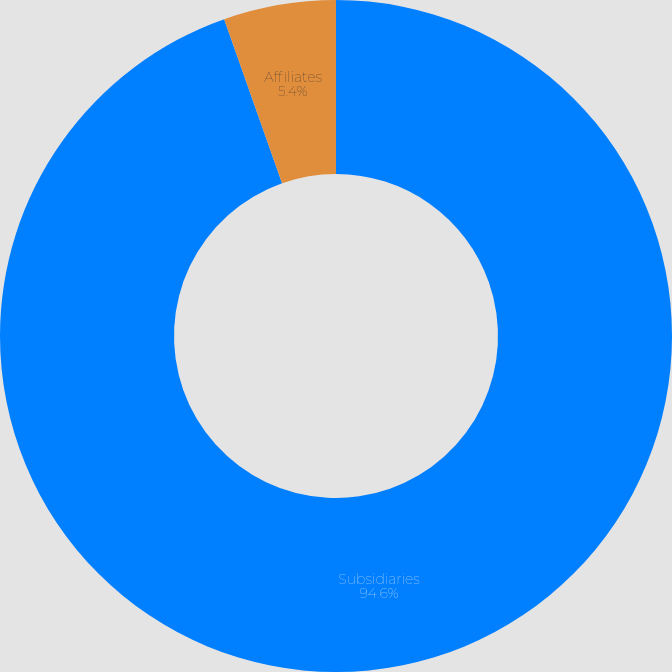Convert chart to OTSL. <chart><loc_0><loc_0><loc_500><loc_500><pie_chart><fcel>Subsidiaries<fcel>Affiliates<nl><fcel>94.6%<fcel>5.4%<nl></chart> 